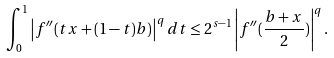<formula> <loc_0><loc_0><loc_500><loc_500>\int _ { 0 } ^ { 1 } \left | f ^ { \prime \prime } ( t x + ( 1 - t ) b ) \right | ^ { q } d t \leq 2 ^ { s - 1 } \left | f ^ { \prime \prime } ( \frac { b + x } { 2 } ) \right | ^ { q } .</formula> 